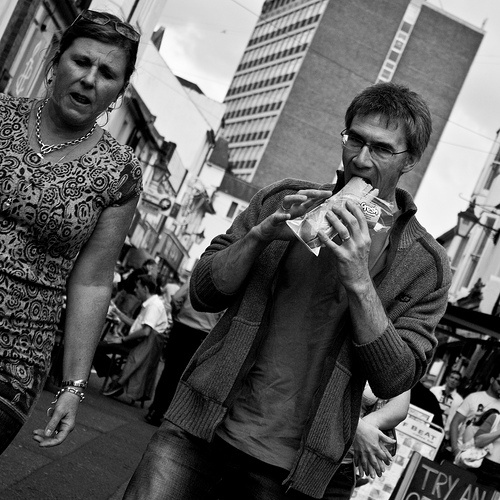Describe the objects in this image and their specific colors. I can see people in lightgray, black, gray, and darkgray tones, people in lightgray, black, gray, and darkgray tones, people in lightgray, black, and gray tones, people in lightgray, darkgray, black, and gray tones, and people in lightgray, black, gray, and darkgray tones in this image. 